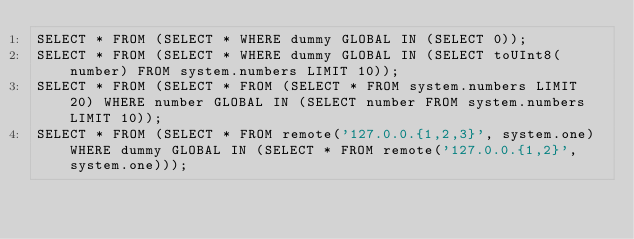Convert code to text. <code><loc_0><loc_0><loc_500><loc_500><_SQL_>SELECT * FROM (SELECT * WHERE dummy GLOBAL IN (SELECT 0));
SELECT * FROM (SELECT * WHERE dummy GLOBAL IN (SELECT toUInt8(number) FROM system.numbers LIMIT 10));
SELECT * FROM (SELECT * FROM (SELECT * FROM system.numbers LIMIT 20) WHERE number GLOBAL IN (SELECT number FROM system.numbers LIMIT 10));
SELECT * FROM (SELECT * FROM remote('127.0.0.{1,2,3}', system.one) WHERE dummy GLOBAL IN (SELECT * FROM remote('127.0.0.{1,2}', system.one)));
</code> 